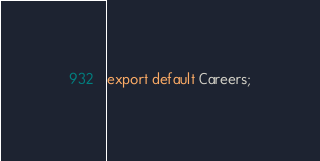<code> <loc_0><loc_0><loc_500><loc_500><_JavaScript_>
export default Careers;
</code> 